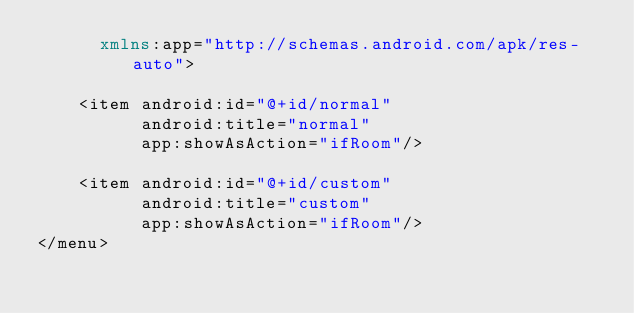Convert code to text. <code><loc_0><loc_0><loc_500><loc_500><_XML_>      xmlns:app="http://schemas.android.com/apk/res-auto">

    <item android:id="@+id/normal"
          android:title="normal"
          app:showAsAction="ifRoom"/>

    <item android:id="@+id/custom"
          android:title="custom"
          app:showAsAction="ifRoom"/>
</menu></code> 